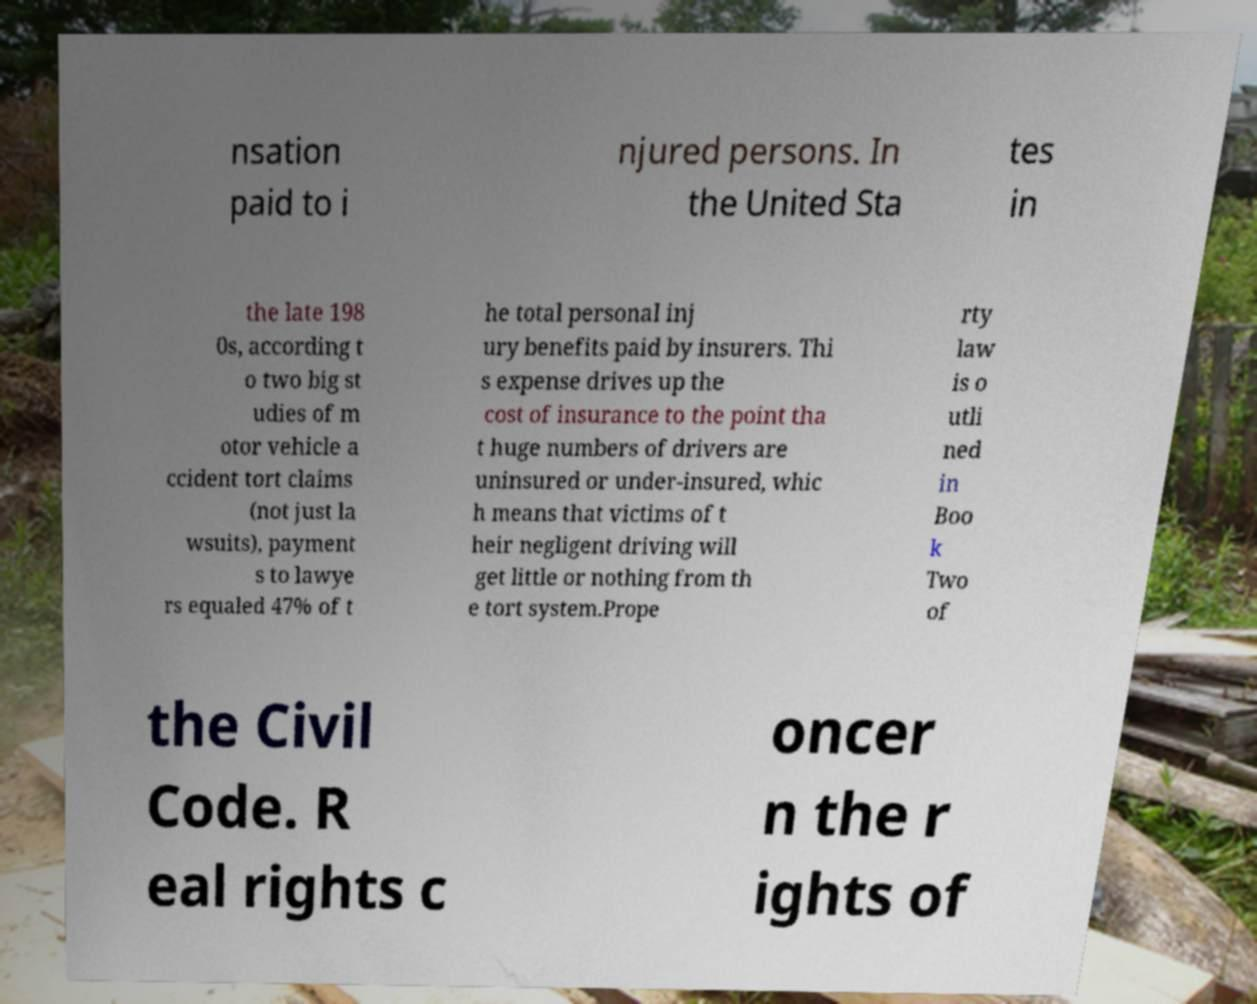What messages or text are displayed in this image? I need them in a readable, typed format. nsation paid to i njured persons. In the United Sta tes in the late 198 0s, according t o two big st udies of m otor vehicle a ccident tort claims (not just la wsuits), payment s to lawye rs equaled 47% of t he total personal inj ury benefits paid by insurers. Thi s expense drives up the cost of insurance to the point tha t huge numbers of drivers are uninsured or under-insured, whic h means that victims of t heir negligent driving will get little or nothing from th e tort system.Prope rty law is o utli ned in Boo k Two of the Civil Code. R eal rights c oncer n the r ights of 